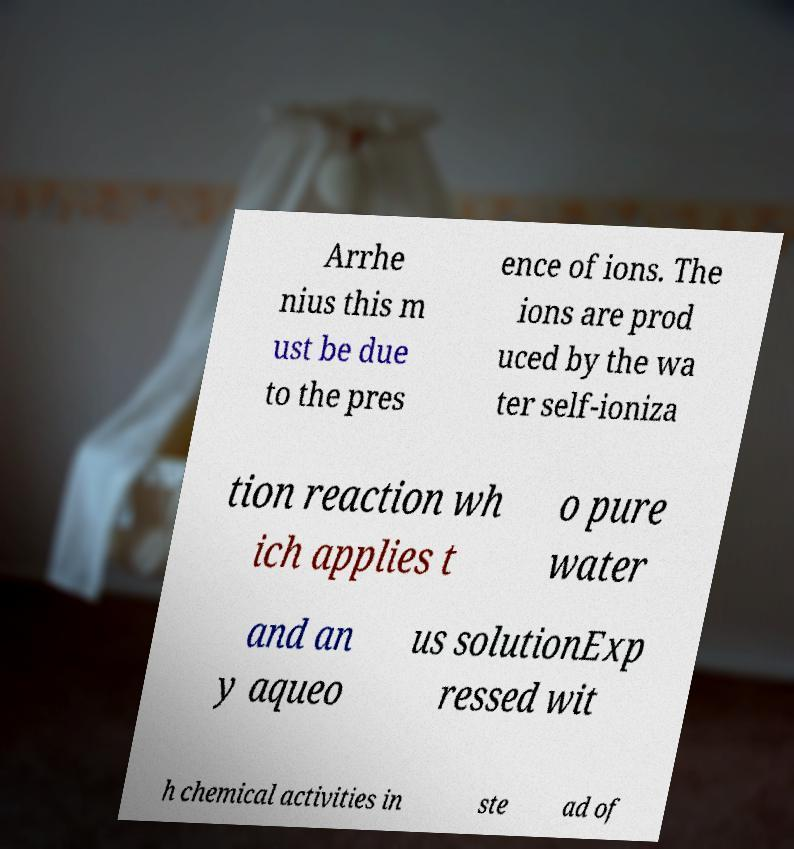For documentation purposes, I need the text within this image transcribed. Could you provide that? Arrhe nius this m ust be due to the pres ence of ions. The ions are prod uced by the wa ter self-ioniza tion reaction wh ich applies t o pure water and an y aqueo us solutionExp ressed wit h chemical activities in ste ad of 